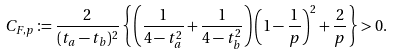Convert formula to latex. <formula><loc_0><loc_0><loc_500><loc_500>C _ { F , p } \coloneqq \frac { 2 } { ( t _ { a } - t _ { b } ) ^ { 2 } } \left \{ \left ( \frac { 1 } { 4 - t _ { a } ^ { 2 } } + \frac { 1 } { 4 - t _ { b } ^ { 2 } } \right ) \left ( 1 - \frac { 1 } { p } \right ) ^ { 2 } + \frac { 2 } { p } \right \} > 0 .</formula> 